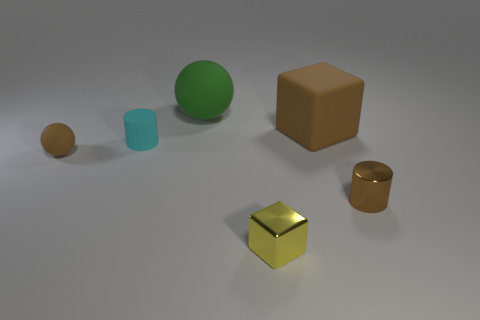Add 3 big green rubber things. How many objects exist? 9 Subtract all cylinders. How many objects are left? 4 Subtract 0 purple cylinders. How many objects are left? 6 Subtract all big gray metallic things. Subtract all small cylinders. How many objects are left? 4 Add 5 tiny brown cylinders. How many tiny brown cylinders are left? 6 Add 3 small green rubber cylinders. How many small green rubber cylinders exist? 3 